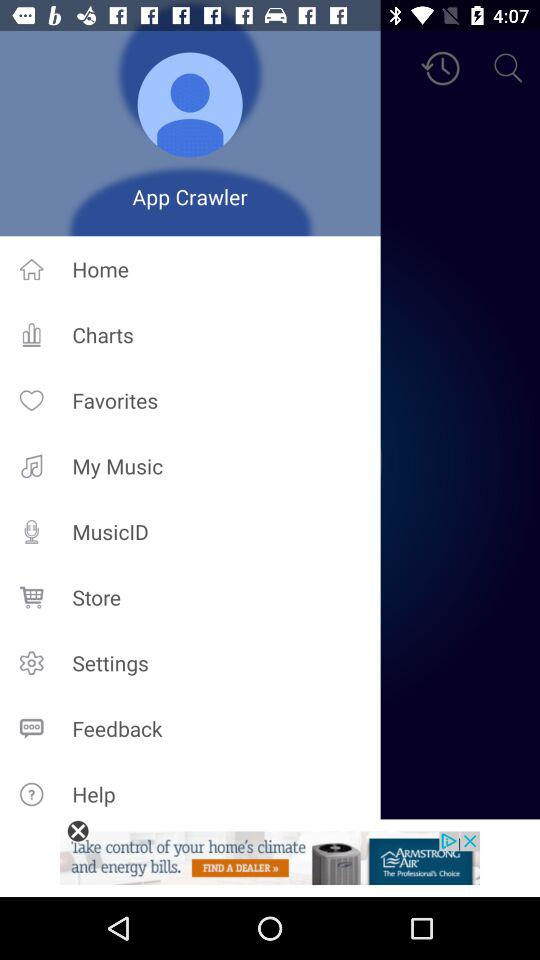What is the user name? The user name is "App Crawler". 